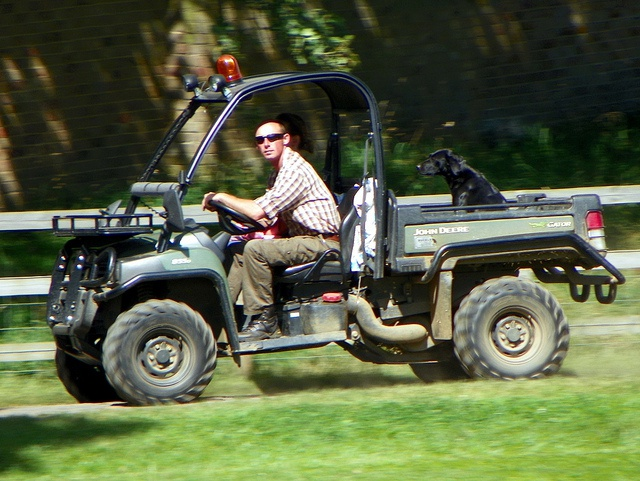Describe the objects in this image and their specific colors. I can see truck in black, gray, darkgray, and ivory tones, car in black, gray, darkgray, and ivory tones, people in black, white, darkgray, and gray tones, dog in black, gray, navy, and darkgreen tones, and people in black, maroon, salmon, and brown tones in this image. 